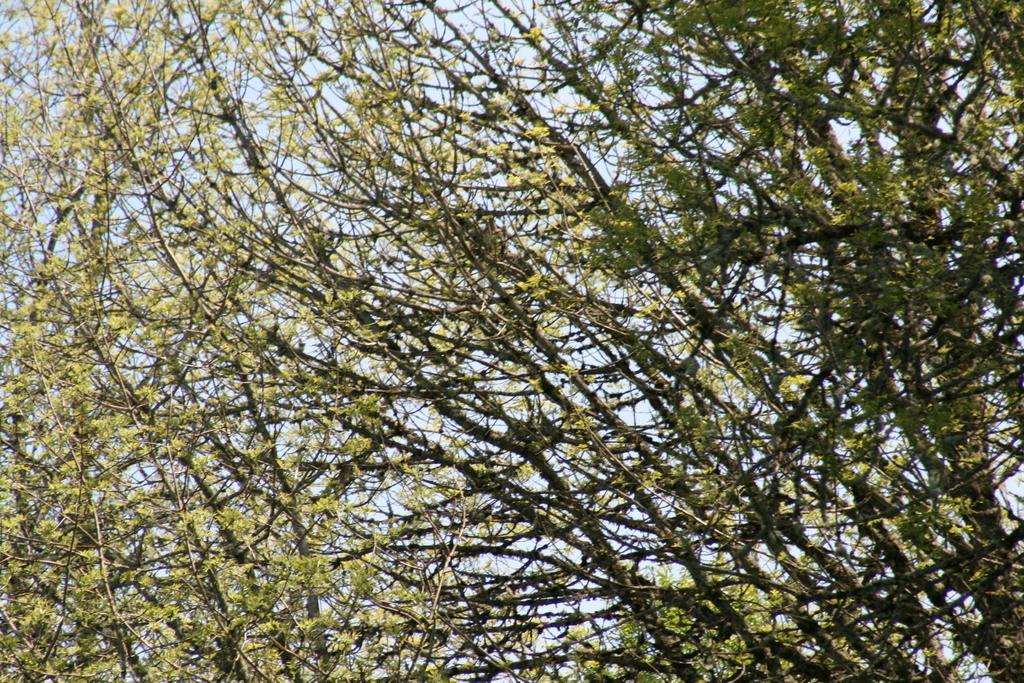Can you describe this image briefly? In this image there are trees,sky. 